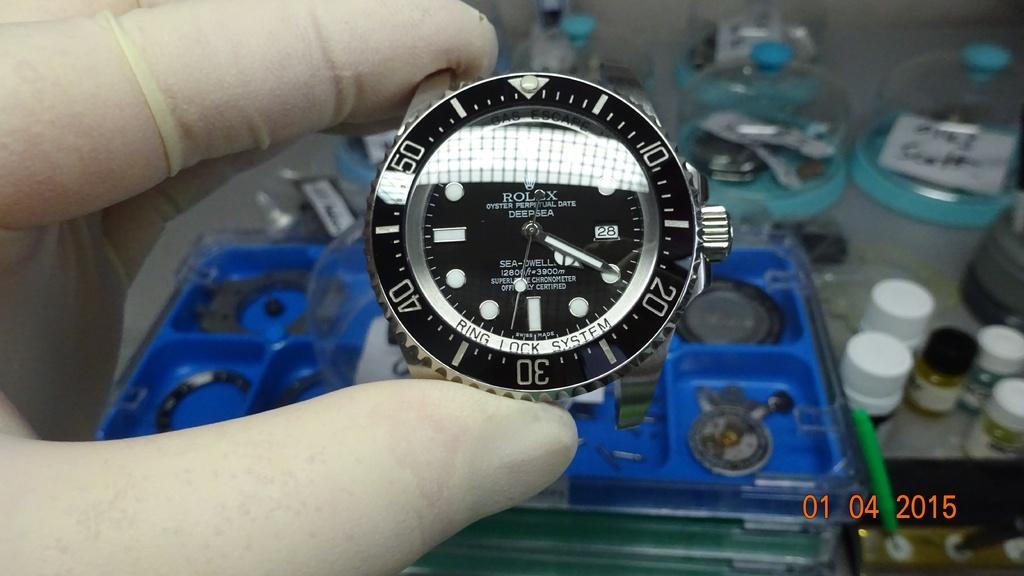<image>
Share a concise interpretation of the image provided. "Rolex Oyster Perpetual Date Deep Sea" is branded onto this watch. 